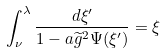Convert formula to latex. <formula><loc_0><loc_0><loc_500><loc_500>\int _ { \nu } ^ { \lambda } \frac { d \xi ^ { \prime } } { 1 - a \widetilde { g } ^ { 2 } \Psi ( \xi ^ { \prime } ) } = \xi</formula> 